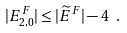Convert formula to latex. <formula><loc_0><loc_0><loc_500><loc_500>| E _ { 2 , 0 } ^ { F } | \leq | \widetilde { E } ^ { F } | - 4 \ .</formula> 